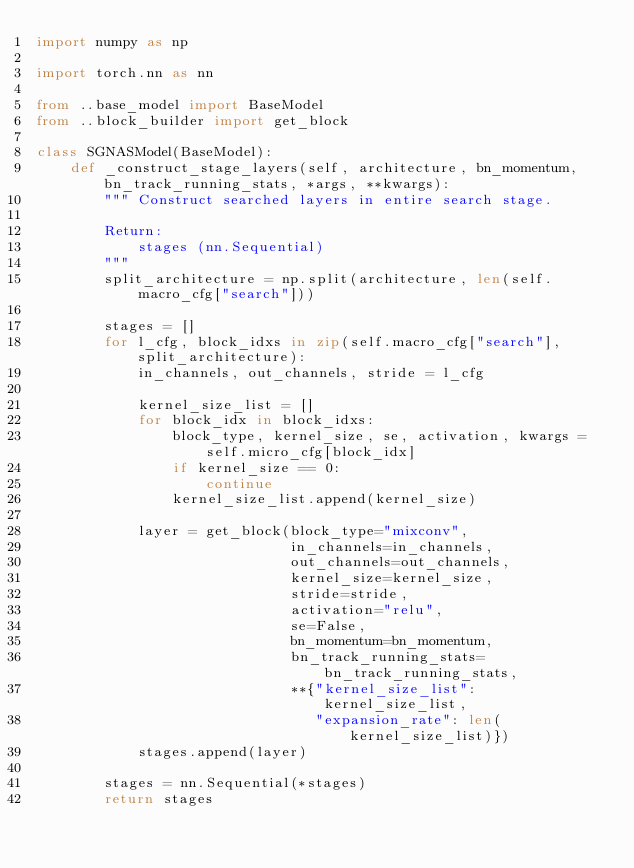Convert code to text. <code><loc_0><loc_0><loc_500><loc_500><_Python_>import numpy as np

import torch.nn as nn

from ..base_model import BaseModel
from ..block_builder import get_block

class SGNASModel(BaseModel):
    def _construct_stage_layers(self, architecture, bn_momentum, bn_track_running_stats, *args, **kwargs):
        """ Construct searched layers in entire search stage.

        Return:
            stages (nn.Sequential)
        """
        split_architecture = np.split(architecture, len(self.macro_cfg["search"]))

        stages = []
        for l_cfg, block_idxs in zip(self.macro_cfg["search"], split_architecture):
            in_channels, out_channels, stride = l_cfg

            kernel_size_list = []
            for block_idx in block_idxs:
                block_type, kernel_size, se, activation, kwargs = self.micro_cfg[block_idx]
                if kernel_size == 0:
                    continue
                kernel_size_list.append(kernel_size)

            layer = get_block(block_type="mixconv",
                              in_channels=in_channels,
                              out_channels=out_channels,
                              kernel_size=kernel_size,
                              stride=stride,
                              activation="relu",
                              se=False,
                              bn_momentum=bn_momentum,
                              bn_track_running_stats=bn_track_running_stats,
                              **{"kernel_size_list": kernel_size_list,
                                 "expansion_rate": len(kernel_size_list)})
            stages.append(layer)

        stages = nn.Sequential(*stages)
        return stages


</code> 